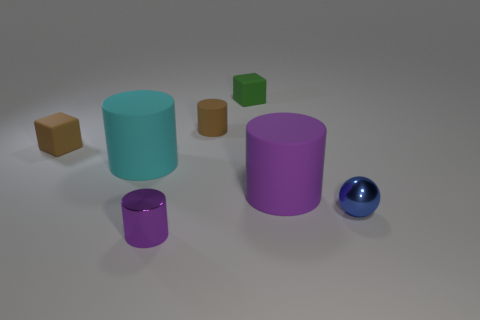Add 2 small shiny cylinders. How many objects exist? 9 Subtract all balls. How many objects are left? 6 Add 2 tiny blue shiny things. How many tiny blue shiny things exist? 3 Subtract 1 brown cylinders. How many objects are left? 6 Subtract all small brown objects. Subtract all tiny purple rubber cylinders. How many objects are left? 5 Add 6 cyan matte cylinders. How many cyan matte cylinders are left? 7 